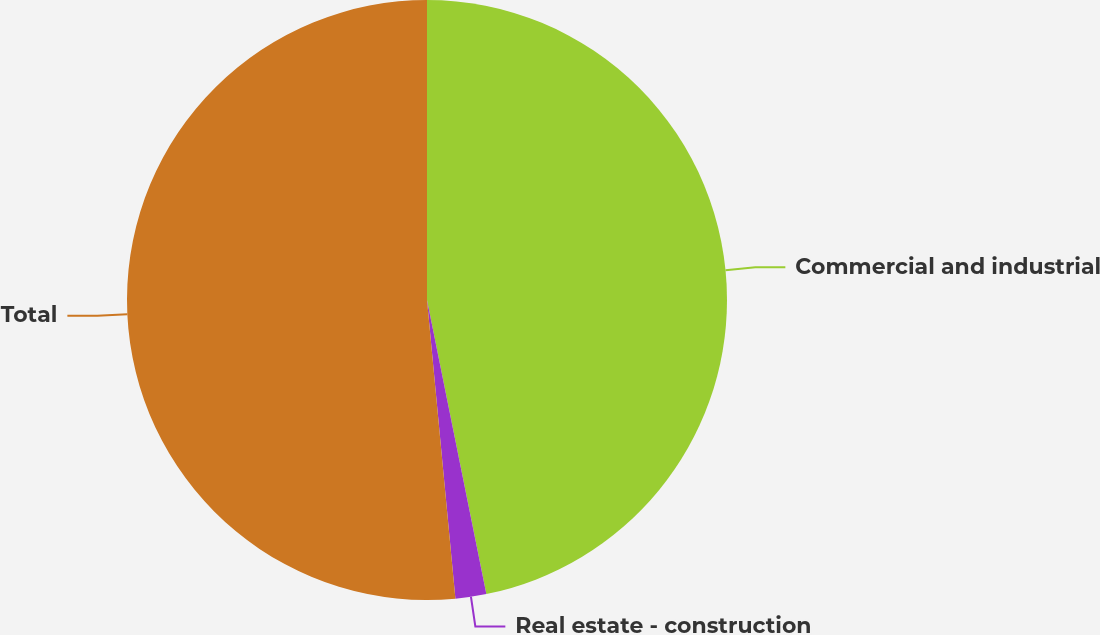Convert chart. <chart><loc_0><loc_0><loc_500><loc_500><pie_chart><fcel>Commercial and industrial<fcel>Real estate - construction<fcel>Total<nl><fcel>46.83%<fcel>1.66%<fcel>51.51%<nl></chart> 